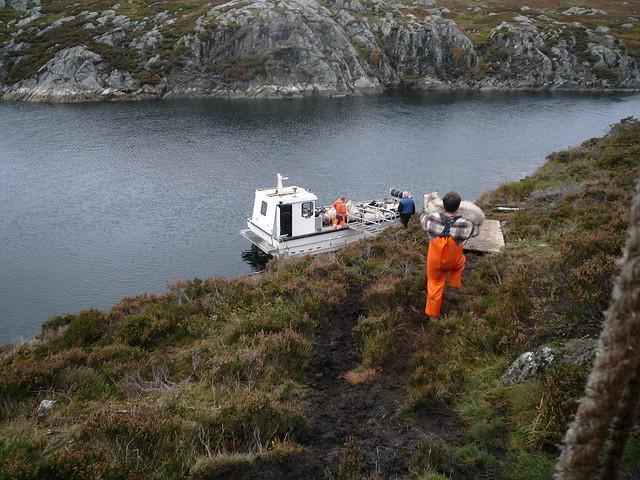How many people can you see?
Give a very brief answer. 1. How many boats are in the photo?
Give a very brief answer. 1. 